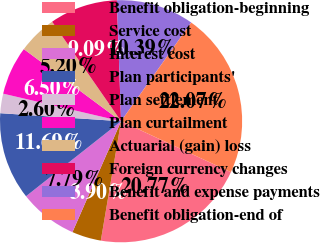Convert chart to OTSL. <chart><loc_0><loc_0><loc_500><loc_500><pie_chart><fcel>Benefit obligation-beginning<fcel>Service cost<fcel>Interest cost<fcel>Plan participants'<fcel>Plan settlement<fcel>Plan curtailment<fcel>Actuarial (gain) loss<fcel>Foreign currency changes<fcel>Benefit and expense payments<fcel>Benefit obligation-end of<nl><fcel>20.77%<fcel>3.9%<fcel>7.79%<fcel>11.69%<fcel>2.6%<fcel>6.5%<fcel>5.2%<fcel>9.09%<fcel>10.39%<fcel>22.07%<nl></chart> 